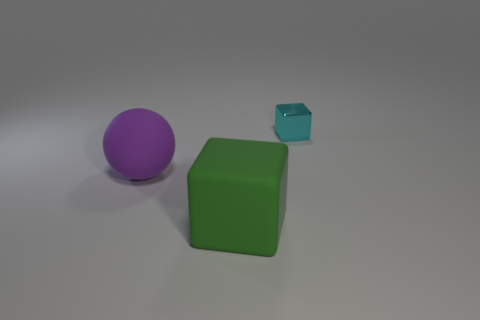Do the rubber object in front of the purple sphere and the cyan metal object have the same shape?
Provide a succinct answer. Yes. How many things are big green rubber cubes or blocks in front of the large purple thing?
Your answer should be compact. 1. Is the cyan cube that is behind the purple sphere made of the same material as the sphere?
Provide a short and direct response. No. Is there anything else that has the same size as the cyan cube?
Your answer should be very brief. No. There is a block that is in front of the large thing that is behind the matte cube; what is its material?
Make the answer very short. Rubber. Is the number of metal things to the right of the shiny block greater than the number of large green matte cubes that are on the right side of the big rubber block?
Keep it short and to the point. No. What is the size of the purple rubber ball?
Offer a very short reply. Large. There is a block that is behind the big rubber ball; is it the same color as the large rubber block?
Keep it short and to the point. No. Are there any other things that have the same shape as the cyan metallic object?
Make the answer very short. Yes. Is there a metal block that is to the right of the big sphere behind the big green matte block?
Provide a succinct answer. Yes. 